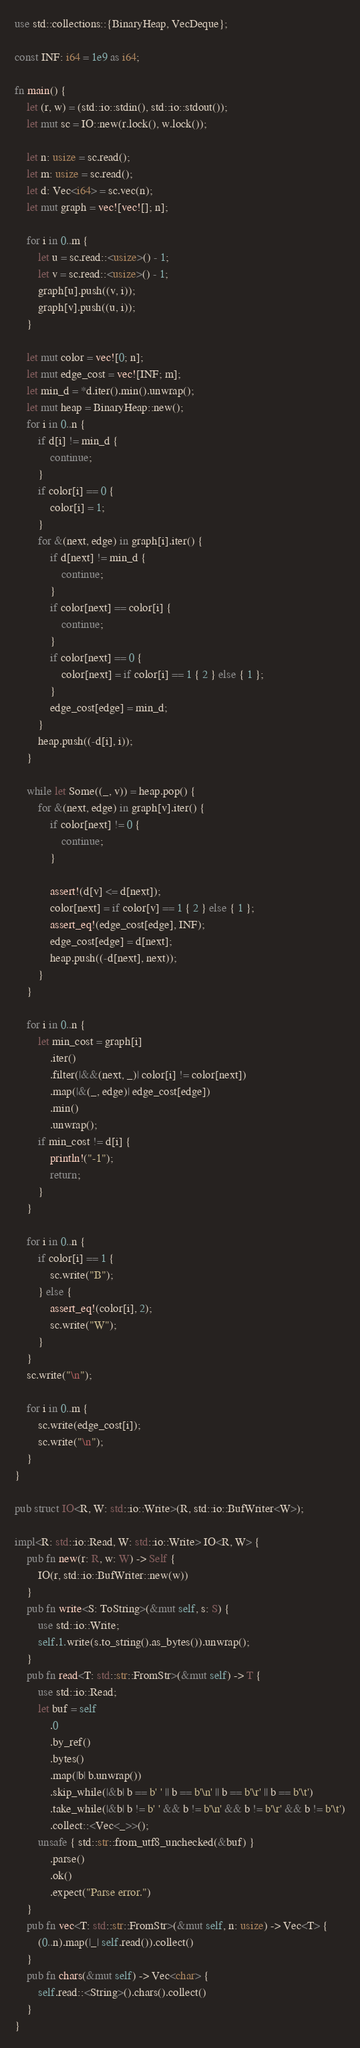Convert code to text. <code><loc_0><loc_0><loc_500><loc_500><_Rust_>use std::collections::{BinaryHeap, VecDeque};

const INF: i64 = 1e9 as i64;

fn main() {
    let (r, w) = (std::io::stdin(), std::io::stdout());
    let mut sc = IO::new(r.lock(), w.lock());

    let n: usize = sc.read();
    let m: usize = sc.read();
    let d: Vec<i64> = sc.vec(n);
    let mut graph = vec![vec![]; n];

    for i in 0..m {
        let u = sc.read::<usize>() - 1;
        let v = sc.read::<usize>() - 1;
        graph[u].push((v, i));
        graph[v].push((u, i));
    }

    let mut color = vec![0; n];
    let mut edge_cost = vec![INF; m];
    let min_d = *d.iter().min().unwrap();
    let mut heap = BinaryHeap::new();
    for i in 0..n {
        if d[i] != min_d {
            continue;
        }
        if color[i] == 0 {
            color[i] = 1;
        }
        for &(next, edge) in graph[i].iter() {
            if d[next] != min_d {
                continue;
            }
            if color[next] == color[i] {
                continue;
            }
            if color[next] == 0 {
                color[next] = if color[i] == 1 { 2 } else { 1 };
            }
            edge_cost[edge] = min_d;
        }
        heap.push((-d[i], i));
    }

    while let Some((_, v)) = heap.pop() {
        for &(next, edge) in graph[v].iter() {
            if color[next] != 0 {
                continue;
            }

            assert!(d[v] <= d[next]);
            color[next] = if color[v] == 1 { 2 } else { 1 };
            assert_eq!(edge_cost[edge], INF);
            edge_cost[edge] = d[next];
            heap.push((-d[next], next));
        }
    }

    for i in 0..n {
        let min_cost = graph[i]
            .iter()
            .filter(|&&(next, _)| color[i] != color[next])
            .map(|&(_, edge)| edge_cost[edge])
            .min()
            .unwrap();
        if min_cost != d[i] {
            println!("-1");
            return;
        }
    }

    for i in 0..n {
        if color[i] == 1 {
            sc.write("B");
        } else {
            assert_eq!(color[i], 2);
            sc.write("W");
        }
    }
    sc.write("\n");

    for i in 0..m {
        sc.write(edge_cost[i]);
        sc.write("\n");
    }
}

pub struct IO<R, W: std::io::Write>(R, std::io::BufWriter<W>);

impl<R: std::io::Read, W: std::io::Write> IO<R, W> {
    pub fn new(r: R, w: W) -> Self {
        IO(r, std::io::BufWriter::new(w))
    }
    pub fn write<S: ToString>(&mut self, s: S) {
        use std::io::Write;
        self.1.write(s.to_string().as_bytes()).unwrap();
    }
    pub fn read<T: std::str::FromStr>(&mut self) -> T {
        use std::io::Read;
        let buf = self
            .0
            .by_ref()
            .bytes()
            .map(|b| b.unwrap())
            .skip_while(|&b| b == b' ' || b == b'\n' || b == b'\r' || b == b'\t')
            .take_while(|&b| b != b' ' && b != b'\n' && b != b'\r' && b != b'\t')
            .collect::<Vec<_>>();
        unsafe { std::str::from_utf8_unchecked(&buf) }
            .parse()
            .ok()
            .expect("Parse error.")
    }
    pub fn vec<T: std::str::FromStr>(&mut self, n: usize) -> Vec<T> {
        (0..n).map(|_| self.read()).collect()
    }
    pub fn chars(&mut self) -> Vec<char> {
        self.read::<String>().chars().collect()
    }
}
</code> 